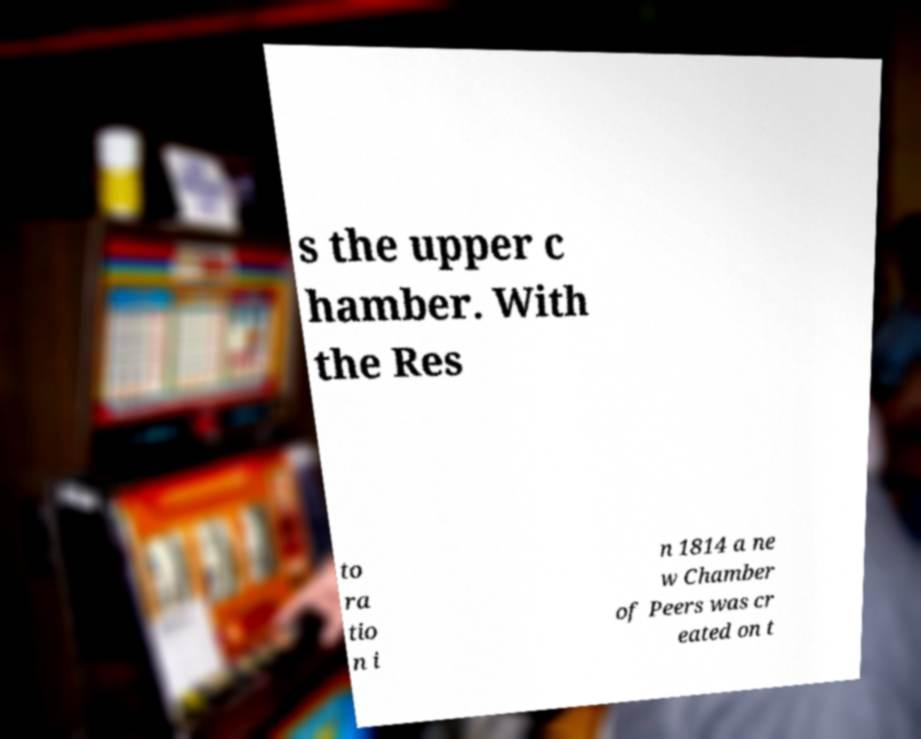There's text embedded in this image that I need extracted. Can you transcribe it verbatim? s the upper c hamber. With the Res to ra tio n i n 1814 a ne w Chamber of Peers was cr eated on t 